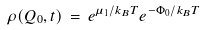<formula> <loc_0><loc_0><loc_500><loc_500>\rho ( Q _ { 0 } , t ) \, = \, e ^ { \mu _ { 1 } / k _ { B } T } e ^ { - \Phi _ { 0 } / k _ { B } T }</formula> 